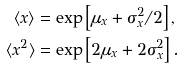Convert formula to latex. <formula><loc_0><loc_0><loc_500><loc_500>\langle x \rangle & = \exp \left [ \mu _ { x } + \sigma _ { x } ^ { 2 } / 2 \right ] , \\ \langle x ^ { 2 } \rangle & = \exp \left [ 2 \mu _ { x } + 2 \sigma _ { x } ^ { 2 } \right ] .</formula> 